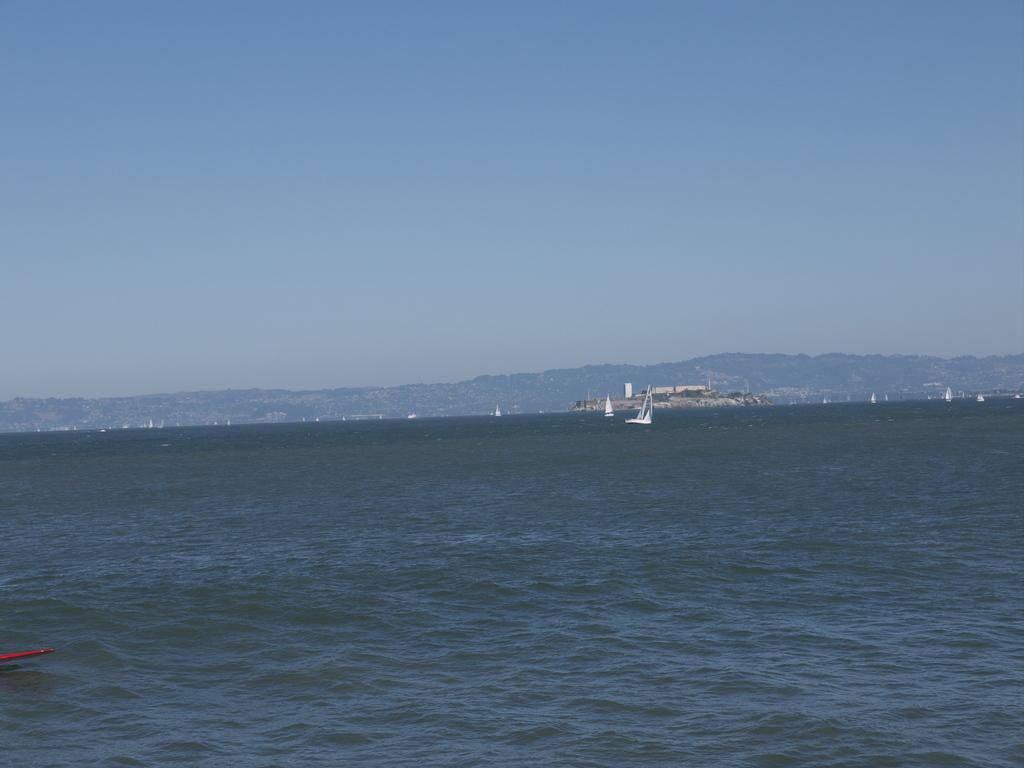Could you give a brief overview of what you see in this image? In this image I can see few boats on the water. In the background I can see few trees, mountains and the sky is in white and blue color. 